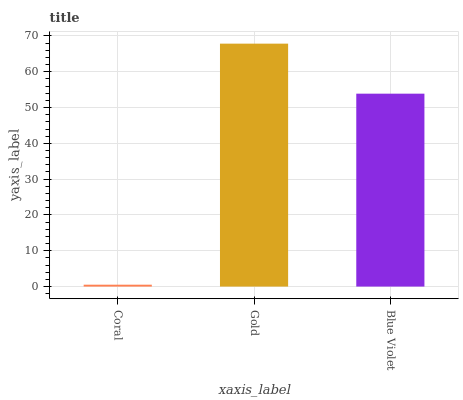Is Coral the minimum?
Answer yes or no. Yes. Is Gold the maximum?
Answer yes or no. Yes. Is Blue Violet the minimum?
Answer yes or no. No. Is Blue Violet the maximum?
Answer yes or no. No. Is Gold greater than Blue Violet?
Answer yes or no. Yes. Is Blue Violet less than Gold?
Answer yes or no. Yes. Is Blue Violet greater than Gold?
Answer yes or no. No. Is Gold less than Blue Violet?
Answer yes or no. No. Is Blue Violet the high median?
Answer yes or no. Yes. Is Blue Violet the low median?
Answer yes or no. Yes. Is Gold the high median?
Answer yes or no. No. Is Gold the low median?
Answer yes or no. No. 